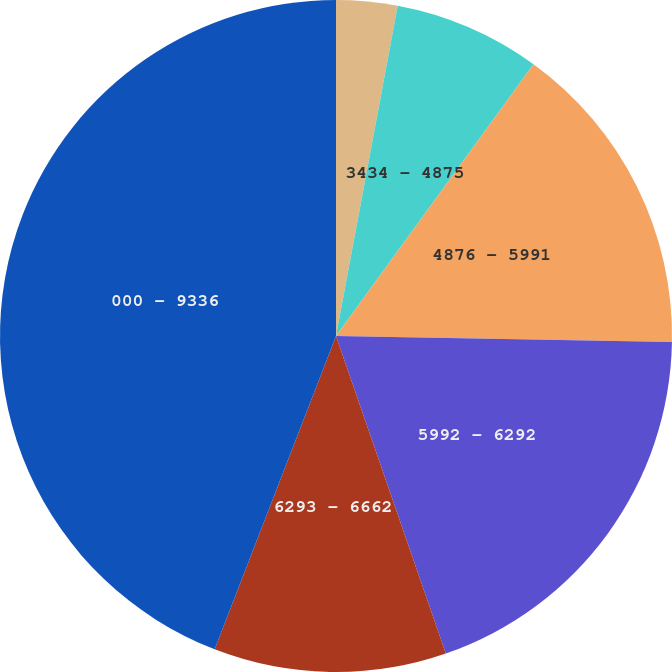Convert chart. <chart><loc_0><loc_0><loc_500><loc_500><pie_chart><fcel>000 - 3433<fcel>3434 - 4875<fcel>4876 - 5991<fcel>5992 - 6292<fcel>6293 - 6662<fcel>000 - 9336<nl><fcel>2.94%<fcel>7.06%<fcel>15.29%<fcel>19.41%<fcel>11.18%<fcel>44.12%<nl></chart> 